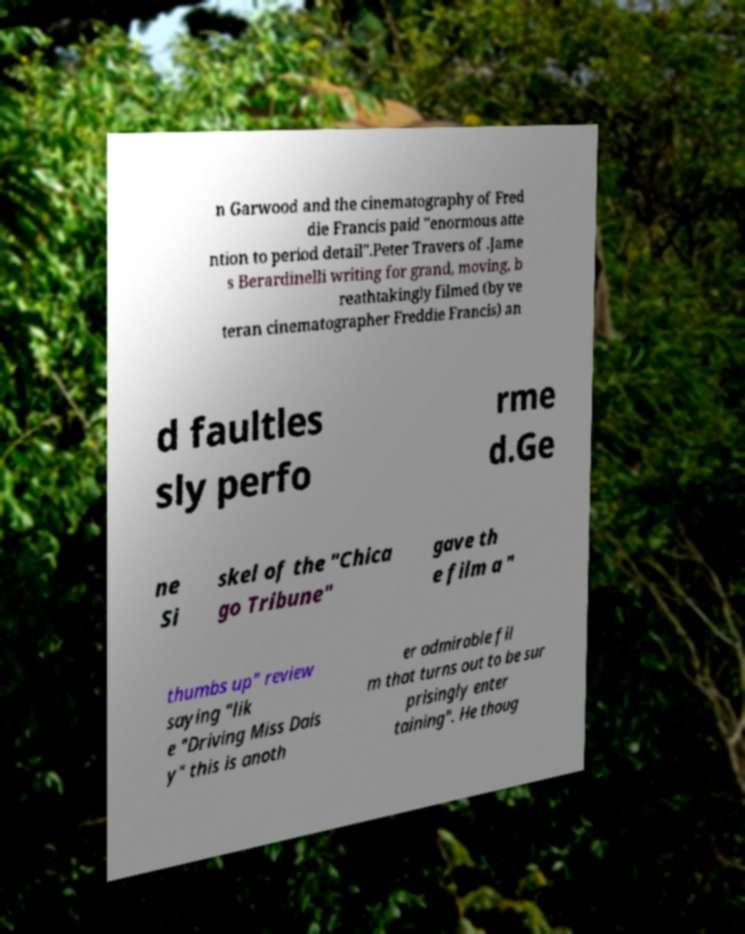Please identify and transcribe the text found in this image. n Garwood and the cinematography of Fred die Francis paid "enormous atte ntion to period detail".Peter Travers of .Jame s Berardinelli writing for grand, moving, b reathtakingly filmed (by ve teran cinematographer Freddie Francis) an d faultles sly perfo rme d.Ge ne Si skel of the "Chica go Tribune" gave th e film a " thumbs up" review saying "lik e "Driving Miss Dais y" this is anoth er admirable fil m that turns out to be sur prisingly enter taining". He thoug 